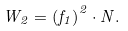<formula> <loc_0><loc_0><loc_500><loc_500>W _ { 2 } = \left ( f _ { 1 } \right ) ^ { 2 } \cdot N .</formula> 